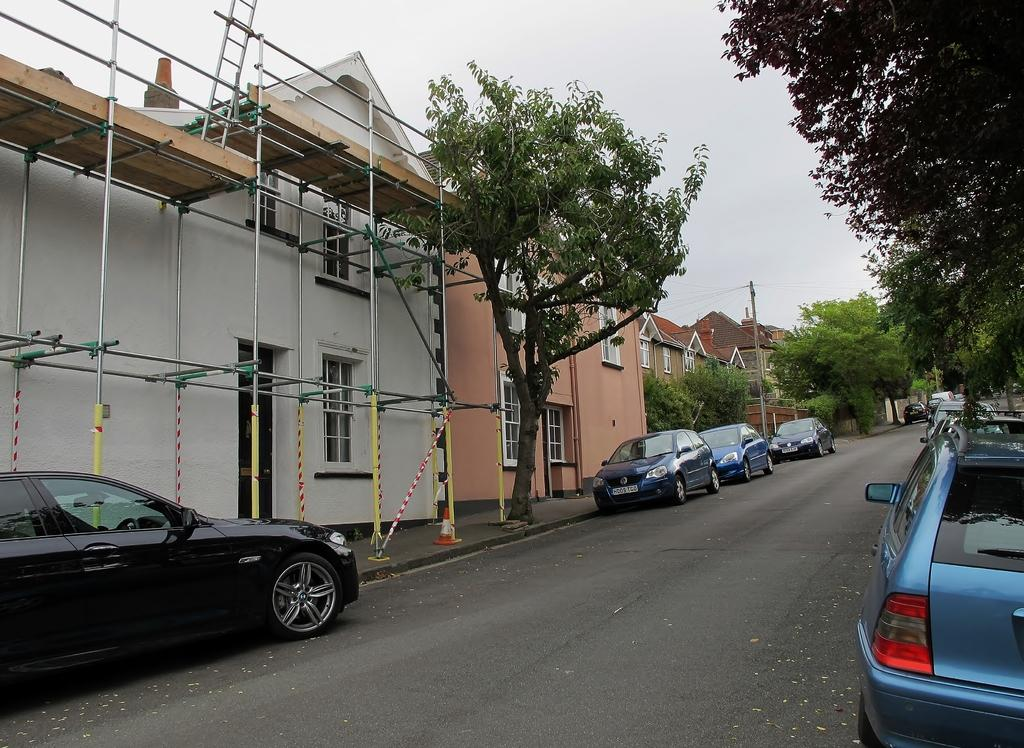What type of structures can be seen in the image? There are houses in the image. What natural elements are present in the image? There are trees in the image. What type of vehicles can be seen in the image? Cars are visible in the image. What type of pathway is present in the image? There is a road in the image. What additional object can be seen in the image? A ladder is present in the image. What type of barrier is visible in the image? There is a fence in the image. What part of the environment is visible in the image? The sky is visible in the image. What type of fight is taking place in the image? There is no fight present in the image. What season is depicted in the image? The provided facts do not mention any season, so it cannot be determined from the image. 